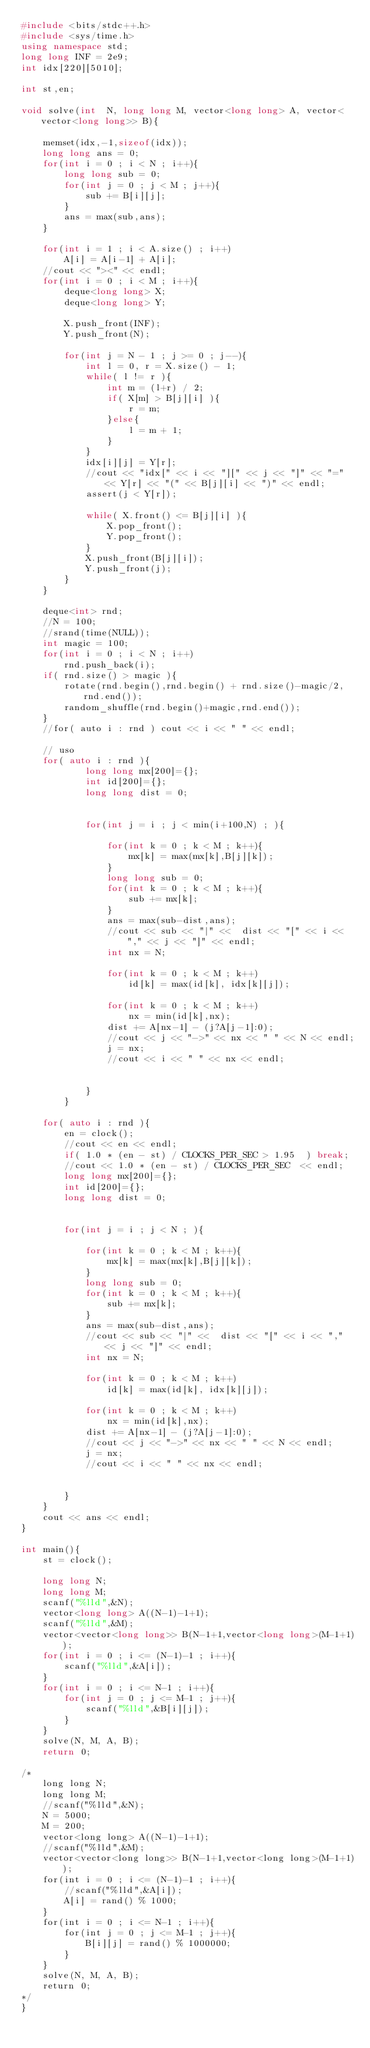<code> <loc_0><loc_0><loc_500><loc_500><_C++_>#include <bits/stdc++.h>
#include <sys/time.h>
using namespace std;
long long INF = 2e9;
int idx[220][5010];

int st,en;

void solve(int  N, long long M, vector<long long> A, vector<vector<long long>> B){
	
	memset(idx,-1,sizeof(idx));
	long long ans = 0;
	for(int i = 0 ; i < N ; i++){
		long long sub = 0;
		for(int j = 0 ; j < M ; j++){	
			sub += B[i][j];
		}
		ans = max(sub,ans);
	}
	
	for(int i = 1 ; i < A.size() ; i++)
		A[i] = A[i-1] + A[i];
	//cout << "><" << endl;
	for(int i = 0 ; i < M ; i++){
		deque<long long> X;
		deque<long long> Y;
		
		X.push_front(INF);
		Y.push_front(N);
		
		for(int j = N - 1 ; j >= 0 ; j--){
			int l = 0, r = X.size() - 1;
			while( l != r ){
				int m = (l+r) / 2;
				if( X[m] > B[j][i] ){
					r = m;
				}else{
					l = m + 1;
				}
			}
			idx[i][j] = Y[r];
			//cout << "idx[" << i << "][" << j << "]" << "=" << Y[r] << "(" << B[j][i] << ")" << endl;
			assert(j < Y[r]);
			
			while( X.front() <= B[j][i] ){
				X.pop_front();
				Y.pop_front();
			}
			X.push_front(B[j][i]);
			Y.push_front(j);
		}
	}
	
	deque<int> rnd;
	//N = 100;
	//srand(time(NULL));
	int magic = 100;
	for(int i = 0 ; i < N ; i++)
		rnd.push_back(i);
	if( rnd.size() > magic ){
		rotate(rnd.begin(),rnd.begin() + rnd.size()-magic/2, rnd.end());
		random_shuffle(rnd.begin()+magic,rnd.end());
	}
	//for( auto i : rnd ) cout << i << " " << endl;
	
	// uso 
	for( auto i : rnd ){
			long long mx[200]={};
			int id[200]={};
			long long dist = 0;
		
		
			for(int j = i ; j < min(i+100,N) ; ){
			
				for(int k = 0 ; k < M ; k++){	
					mx[k] = max(mx[k],B[j][k]);
				}
				long long sub = 0;
				for(int k = 0 ; k < M ; k++){	
					sub += mx[k];
				}
				ans = max(sub-dist,ans);
				//cout << sub << "|" <<  dist << "[" << i << "," << j << "]" << endl;
				int nx = N;
			
				for(int k = 0 ; k < M ; k++)
					id[k] = max(id[k], idx[k][j]);
			
				for(int k = 0 ; k < M ; k++)
					nx = min(id[k],nx);
				dist += A[nx-1] - (j?A[j-1]:0);
				//cout << j << "->" << nx << " " << N << endl;
				j = nx;
				//cout << i << " " << nx << endl;
			
			
			}
		}
	
	for( auto i : rnd ){
		en = clock();
		//cout << en << endl;
		if( 1.0 * (en - st) / CLOCKS_PER_SEC > 1.95  ) break;
		//cout << 1.0 * (en - st) / CLOCKS_PER_SEC  << endl;
		long long mx[200]={};
		int id[200]={};
		long long dist = 0;
		
		
		for(int j = i ; j < N ; ){
			
			for(int k = 0 ; k < M ; k++){	
				mx[k] = max(mx[k],B[j][k]);
			}
			long long sub = 0;
			for(int k = 0 ; k < M ; k++){	
				sub += mx[k];
			}
			ans = max(sub-dist,ans);
			//cout << sub << "|" <<  dist << "[" << i << "," << j << "]" << endl;
			int nx = N;
			
			for(int k = 0 ; k < M ; k++)
				id[k] = max(id[k], idx[k][j]);
			
			for(int k = 0 ; k < M ; k++)
				nx = min(id[k],nx);
			dist += A[nx-1] - (j?A[j-1]:0);
			//cout << j << "->" << nx << " " << N << endl;
			j = nx;
			//cout << i << " " << nx << endl;
			
			
		}
	}
	cout << ans << endl;
}

int main(){
	st = clock();

	long long N;
	long long M;
	scanf("%lld",&N);
	vector<long long> A((N-1)-1+1);
	scanf("%lld",&M);
	vector<vector<long long>> B(N-1+1,vector<long long>(M-1+1));
	for(int i = 0 ; i <= (N-1)-1 ; i++){
		scanf("%lld",&A[i]);
	}
	for(int i = 0 ; i <= N-1 ; i++){
		for(int j = 0 ; j <= M-1 ; j++){
			scanf("%lld",&B[i][j]);
		}
	}
	solve(N, M, A, B);
	return 0;

/*
	long long N;
	long long M;
	//scanf("%lld",&N);
	N = 5000;
	M = 200;
	vector<long long> A((N-1)-1+1);
	//scanf("%lld",&M);
	vector<vector<long long>> B(N-1+1,vector<long long>(M-1+1));
	for(int i = 0 ; i <= (N-1)-1 ; i++){
		//scanf("%lld",&A[i]);
		A[i] = rand() % 1000;
	}
	for(int i = 0 ; i <= N-1 ; i++){
		for(int j = 0 ; j <= M-1 ; j++){
			B[i][j] = rand() % 1000000;
		}
	}
	solve(N, M, A, B);
	return 0;
*/
}
</code> 